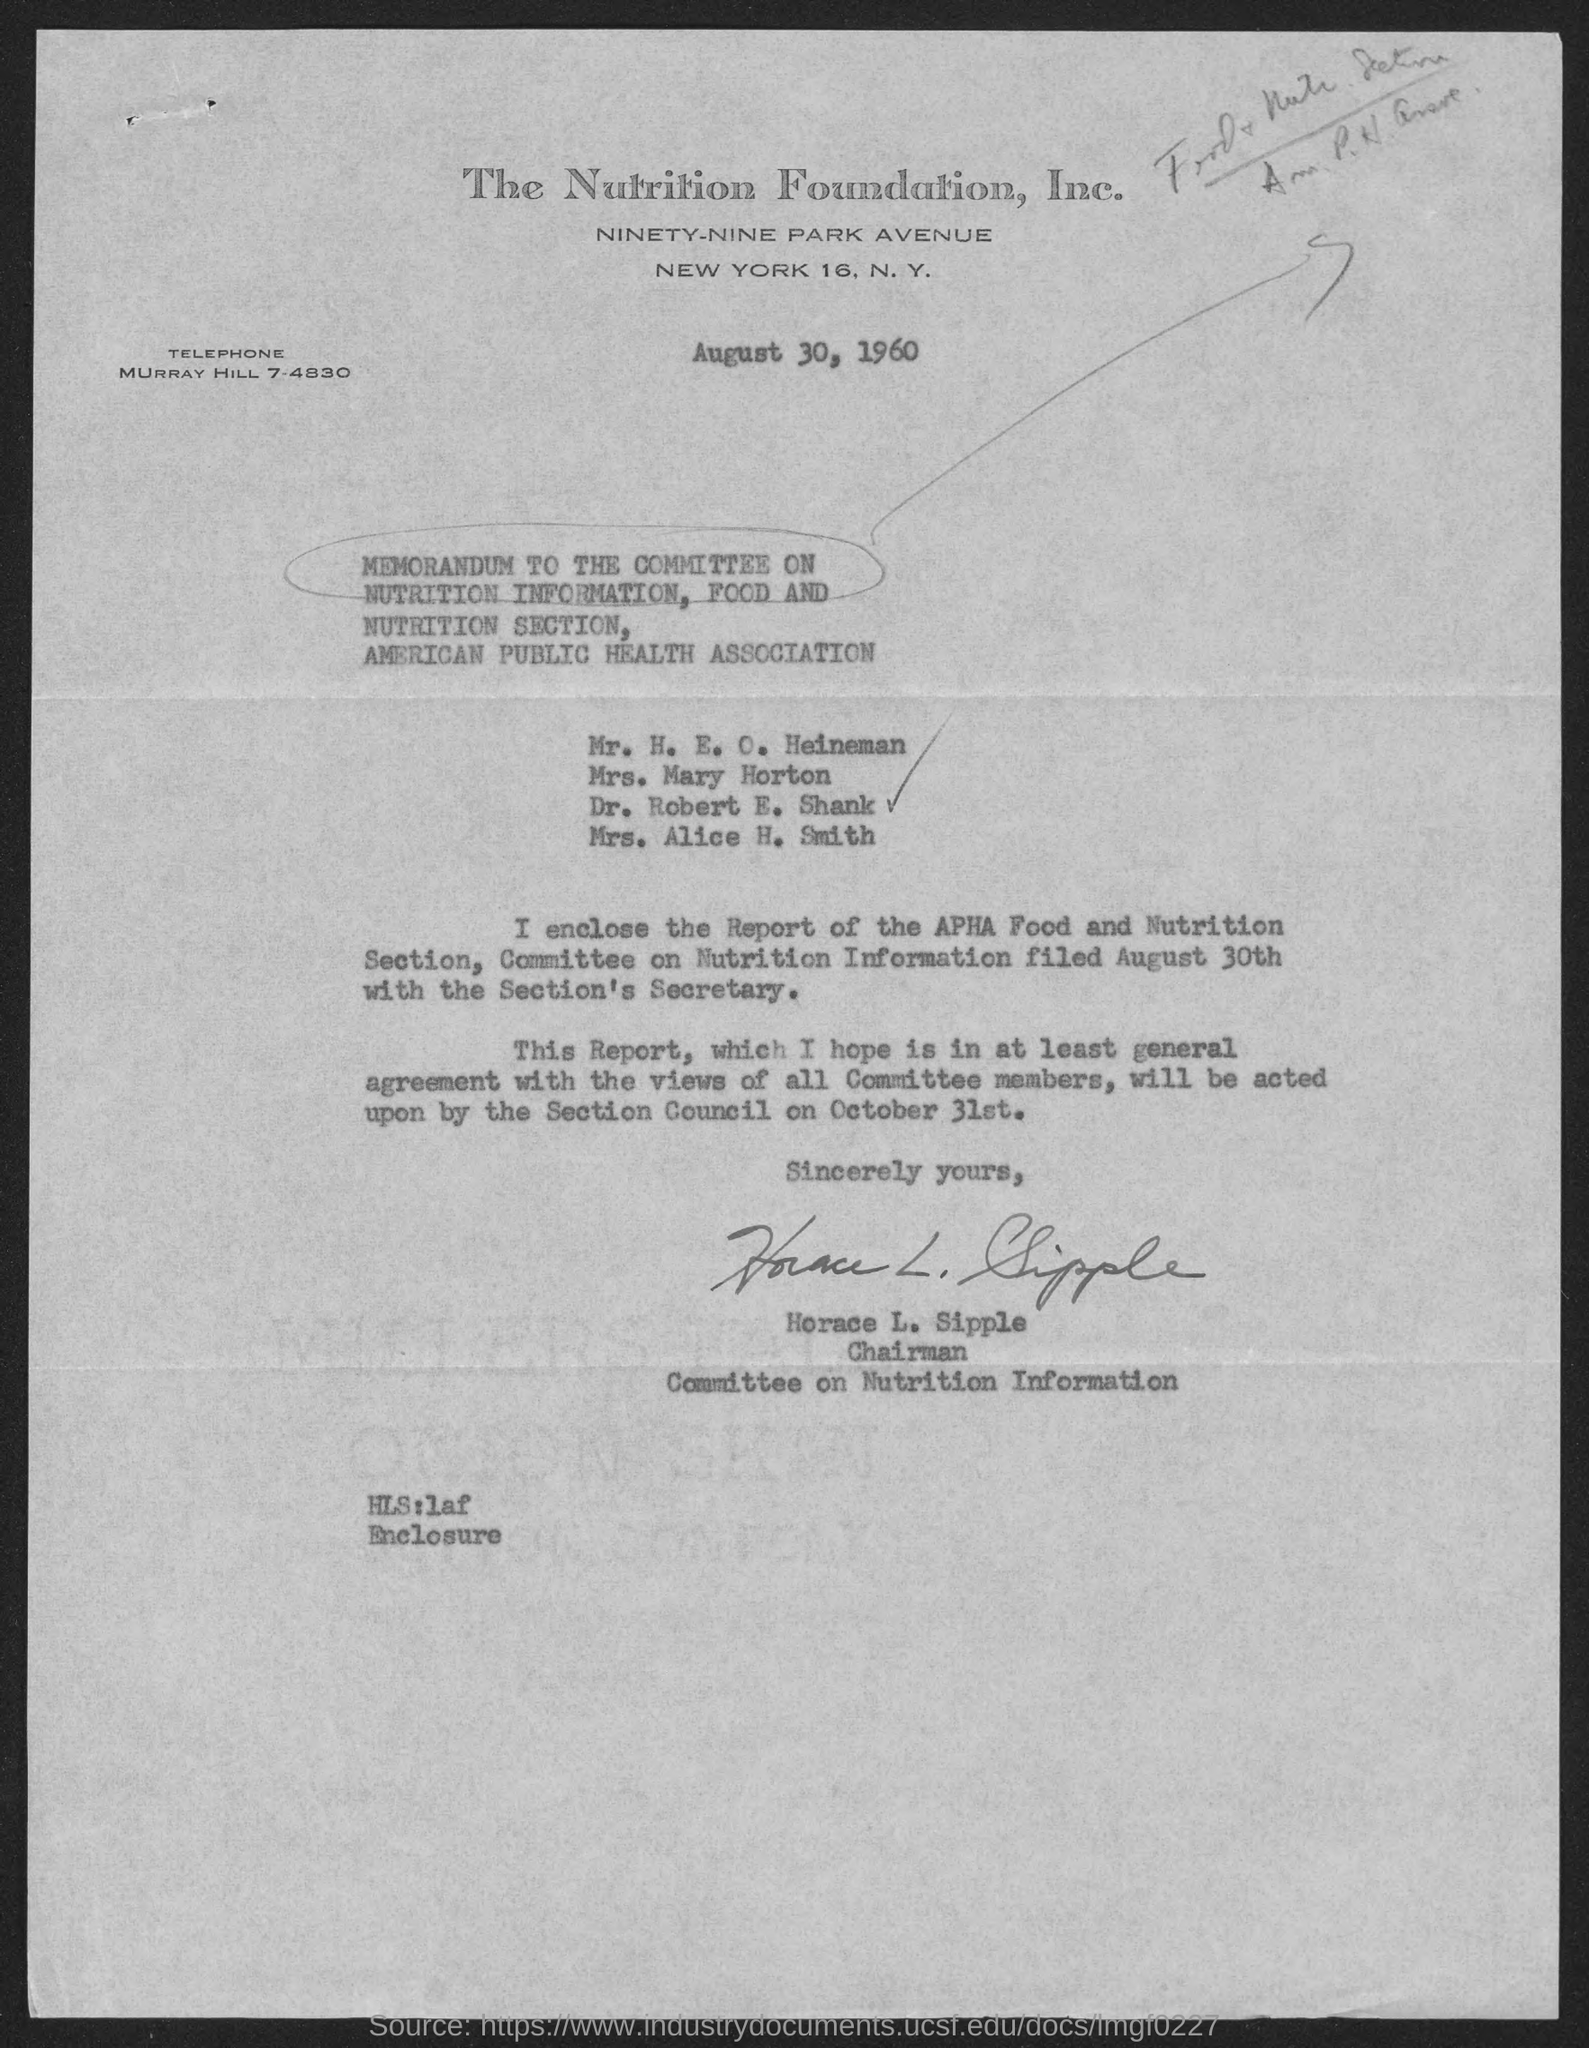What is the position of horace l. sipple ?
Offer a terse response. Chairman. When is the letter dated ?
Offer a terse response. August 30, 1960. 